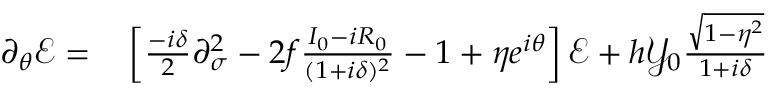Convert formula to latex. <formula><loc_0><loc_0><loc_500><loc_500>\begin{array} { r l } { \partial _ { \theta } \mathcal { E } = } & \left [ \frac { - i \delta } { 2 } \partial _ { \sigma } ^ { 2 } - 2 f \frac { I _ { 0 } - i R _ { 0 } } { ( 1 + i \delta ) ^ { 2 } } - 1 + \eta e ^ { i \theta } \right ] \mathcal { E } + h \mathcal { Y } _ { 0 } \frac { \sqrt { 1 - \eta ^ { 2 } } } { 1 + i \delta } } \end{array}</formula> 